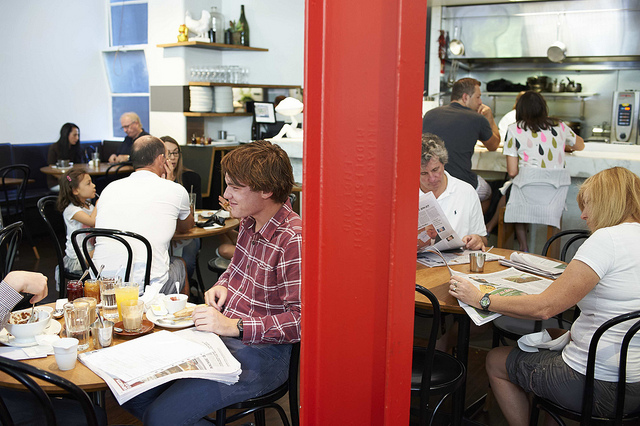What are the people in the image doing? Most of the individuals in the image appear to be engaged in typical dining activities, such as eating, reading newspapers, and having conversations, indicating a relaxed and comfortable ambience. Do you think this place is popular for breakfast or lunch? Given the presence of coffee cups and what appears to be morning light streaming in, combined with the relaxed energy and newspapers, it suggests that this establishment might be a popular spot for breakfast or a mid-morning snack. 